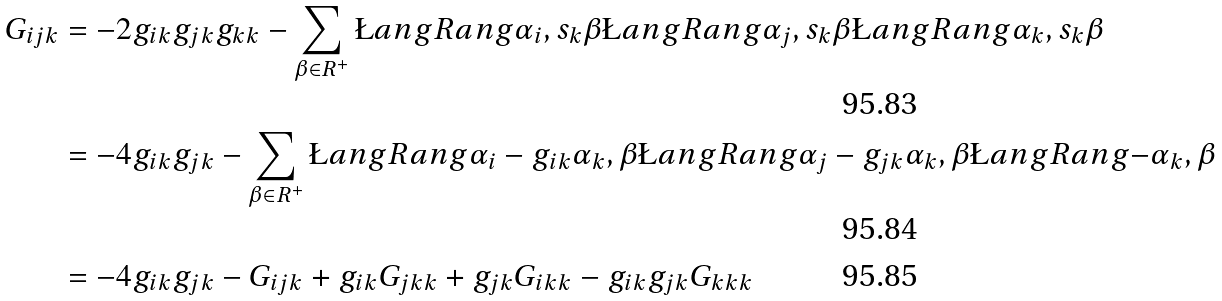<formula> <loc_0><loc_0><loc_500><loc_500>G _ { i j k } & = - 2 g _ { i k } g _ { j k } g _ { k k } - \sum _ { \beta \in R ^ { + } } \L a n g R a n g { \alpha _ { i } , s _ { k } \beta } \L a n g R a n g { \alpha _ { j } , s _ { k } \beta } \L a n g R a n g { \alpha _ { k } , s _ { k } \beta } \\ & = - 4 g _ { i k } g _ { j k } - \sum _ { \beta \in R ^ { + } } \L a n g R a n g { \alpha _ { i } - g _ { i k } \alpha _ { k } , \beta } \L a n g R a n g { \alpha _ { j } - g _ { j k } \alpha _ { k } , \beta } \L a n g R a n g { - \alpha _ { k } , \beta } \\ & = - 4 g _ { i k } g _ { j k } - G _ { i j k } + g _ { i k } G _ { j k k } + g _ { j k } G _ { i k k } - g _ { i k } g _ { j k } G _ { k k k }</formula> 